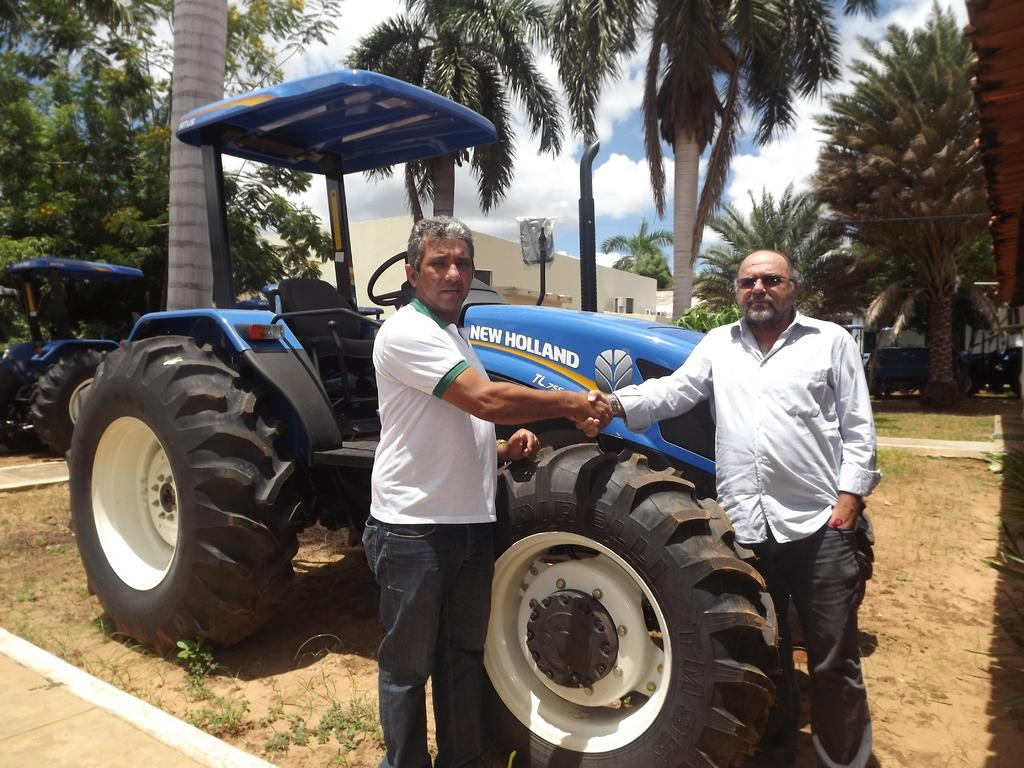How many men are in the image? There are two men in the image. What are the men doing in the image? The men are shaking hands in the image. What is the surface on which the men are standing? The men are standing on the ground in the image. What type of natural elements can be seen in the image? There are trees in the image. What type of man-made structures can be seen in the image? There are buildings in the image. What type of vehicles can be seen in the image? There are tractors in the image. What is visible in the background of the image? The sky is visible in the background of the image. What can be seen in the sky? Clouds are present in the sky in the image. What type of disease is affecting the chicken in the image? There is no chicken present in the image, so it is not possible to determine if any disease is affecting it. 